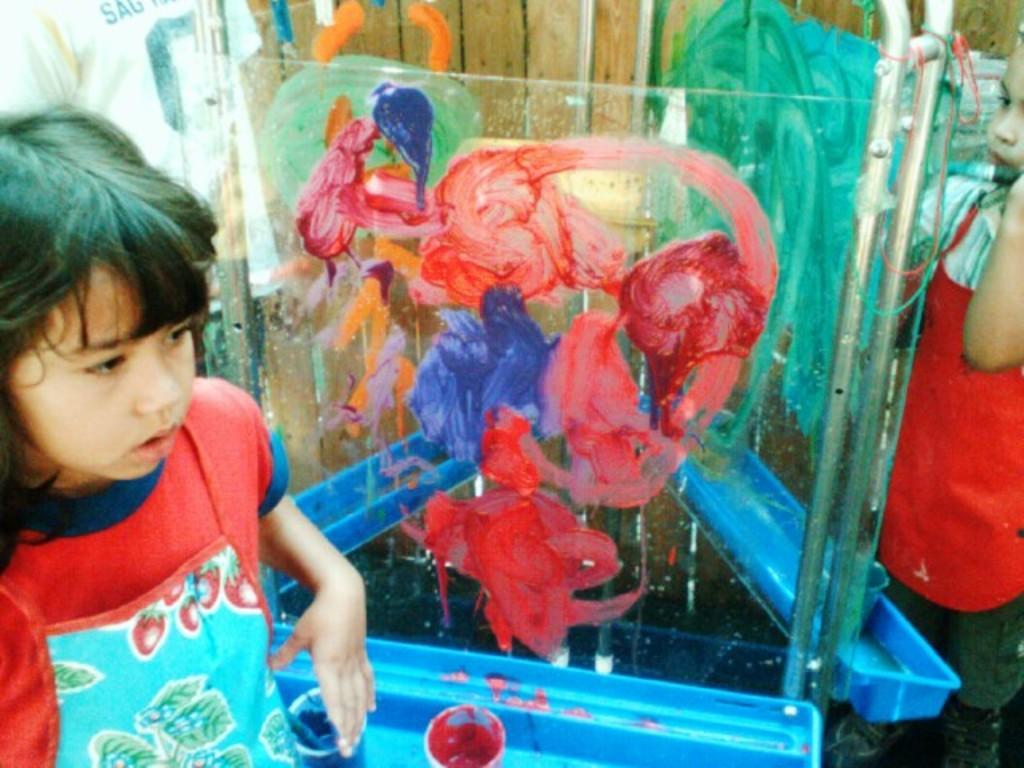Please provide a concise description of this image. In this image I can see two children wearing white, red and blue colored dresses are standing. I can see the glass surface and blue colored object in front of them. On the glass surface I can see the painting and few pain bowls on the blue colored object. In the background I can see the wooden wall and a person wearing white colored dress. 